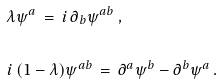Convert formula to latex. <formula><loc_0><loc_0><loc_500><loc_500>& \lambda \psi ^ { a } \, = \, i \, \partial _ { b } \psi ^ { a b } \, , \\ & \\ & i \, ( 1 - \lambda ) \psi ^ { a b } \, = \, \partial ^ { a } \psi ^ { b } - \partial ^ { b } \psi ^ { a } \, .</formula> 